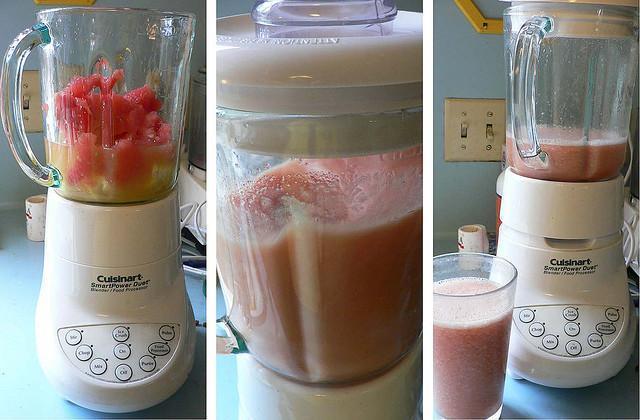How many people are on the ski lift?
Give a very brief answer. 0. 